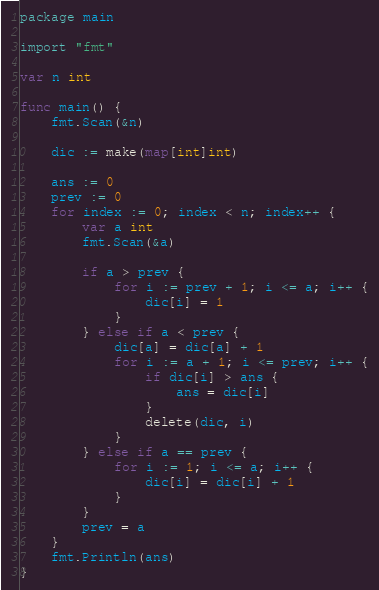Convert code to text. <code><loc_0><loc_0><loc_500><loc_500><_Go_>package main

import "fmt"

var n int

func main() {
	fmt.Scan(&n)

	dic := make(map[int]int)

	ans := 0
	prev := 0
	for index := 0; index < n; index++ {
		var a int
		fmt.Scan(&a)

		if a > prev {
			for i := prev + 1; i <= a; i++ {
				dic[i] = 1
			}
		} else if a < prev {
			dic[a] = dic[a] + 1
			for i := a + 1; i <= prev; i++ {
				if dic[i] > ans {
					ans = dic[i]
				}
				delete(dic, i)
			}
		} else if a == prev {
			for i := 1; i <= a; i++ {
				dic[i] = dic[i] + 1
			}
		}
		prev = a
	}
	fmt.Println(ans)
}
</code> 